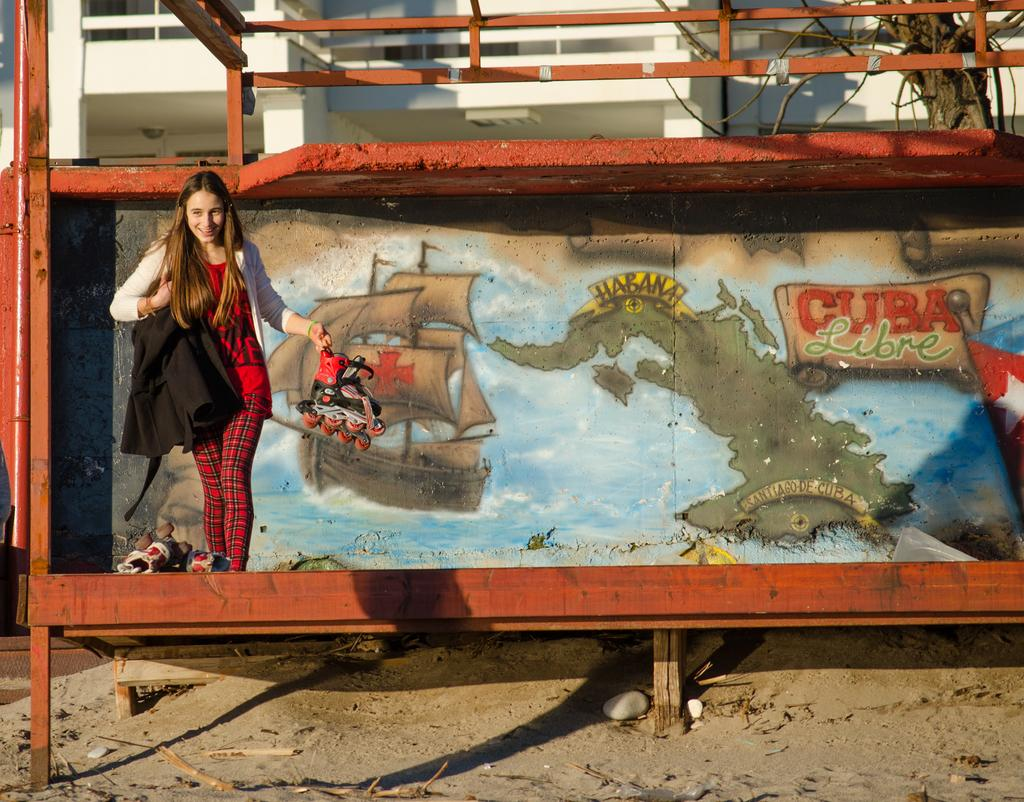Who is the main subject in the image? There is a woman in the image. What is located behind the woman? There is a painting behind the woman. What type of material is used for the rods visible in the image? There are metal rods visible in the image. What type of natural element can be seen in the image? There is a tree in the image. What type of man-made structure is present in the image? There is a building in the image. What type of drum is the maid playing in the image? There is no drum or maid present in the image. 